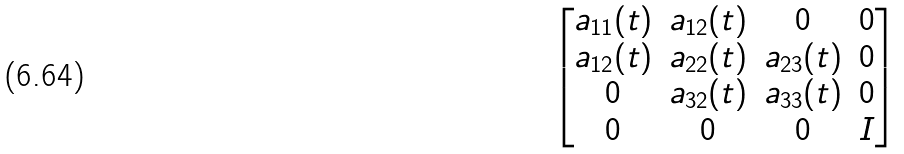<formula> <loc_0><loc_0><loc_500><loc_500>\begin{bmatrix} a _ { 1 1 } ( t ) & a _ { 1 2 } ( t ) & 0 & 0 \\ a _ { 1 2 } ( t ) & a _ { 2 2 } ( t ) & a _ { 2 3 } ( t ) & 0 \\ 0 & a _ { 3 2 } ( t ) & a _ { 3 3 } ( t ) & 0 \\ 0 & 0 & 0 & I \end{bmatrix}</formula> 